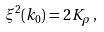<formula> <loc_0><loc_0><loc_500><loc_500>\xi ^ { 2 } ( k _ { 0 } ) = 2 K _ { \rho } \, ,</formula> 